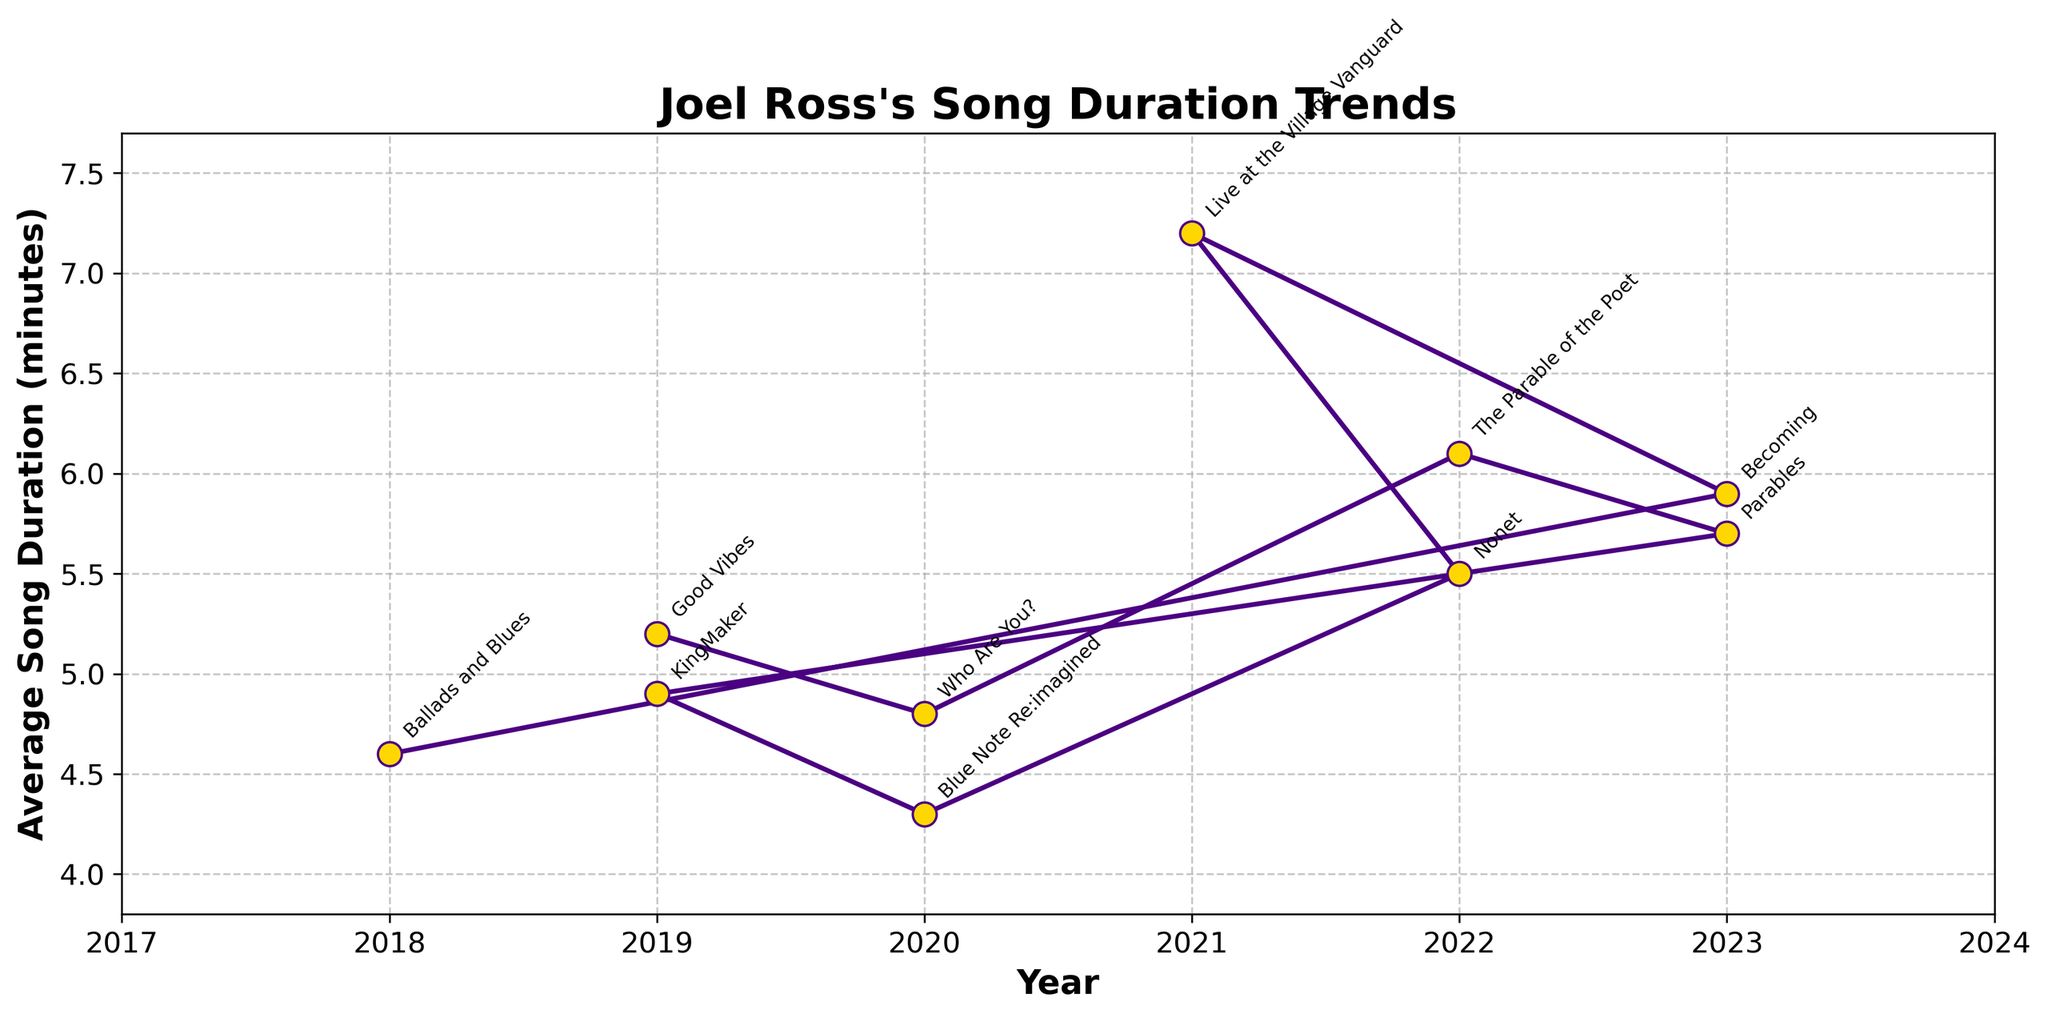What's the trend in Joel Ross's song duration from 2018 to 2023? Starting from 2018 with 'Ballads and Blues' at 4.6 minutes, the average song duration increased and fluctuated over the subsequent years. It peaked in 2021 with 'Live at the Village Vanguard' at 7.2 minutes and slightly declined towards 2023.
Answer: Overall increasing but with fluctuations Which album has the longest average song duration? The album 'Live at the Village Vanguard' in 2021 has the highest average song duration, reaching 7.2 minutes, as indicated by the highest point on the plot.
Answer: Live at the Village Vanguard Compare the average song durations of 'Good Vibes' and 'Who Are You?'. Which one is longer? 'Good Vibes' has an average song duration of 5.2 minutes, while 'Who Are You?' has 4.8 minutes. Therefore, 'Good Vibes' is longer.
Answer: Good Vibes By how much did the average song duration change from 2020 to 2022? The average song duration in 2020 was 4.8 minutes ('Who Are You?') and 4.3 minutes ('Blue Note Re:imagined'), while in 2022 it was 6.1 minutes ('The Parable of the Poet') and 5.5 minutes ('Nonet'). The change can be calculated as (6.1 + 5.5)/2 - (4.8 + 4.3)/2 = 5.8 - 4.55 = 1.25 minutes increase on average.
Answer: Increased by 1.25 minutes How does the average duration of 'Parables' compare to 'Nonet'? The average song duration of 'Parables' is 5.7 minutes, while 'Nonet' is 5.5 minutes. 'Parables' has a slightly longer duration.
Answer: Parables is longer What's the difference in song duration between the shortest and longest albums? The shortest album is 'Blue Note Re:imagined' at 4.3 minutes, and the longest is 'Live at the Village Vanguard' at 7.2 minutes. The difference is 7.2 - 4.3 = 2.9 minutes.
Answer: 2.9 minutes Identify the album with the shortest songs and state its year of release. 'Blue Note Re:imagined' has the shortest average song duration at 4.3 minutes and was released in 2020, as shown at the lowest point on the plot.
Answer: Blue Note Re:imagined, 2020 What's the average of the average song durations for albums released in 2019? For 2019, 'Good Vibes' has 5.2 minutes and 'KingMaker' has 4.9 minutes. The average is (5.2 + 4.9) / 2 = 5.05 minutes.
Answer: 5.05 minutes 